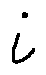Convert formula to latex. <formula><loc_0><loc_0><loc_500><loc_500>i</formula> 